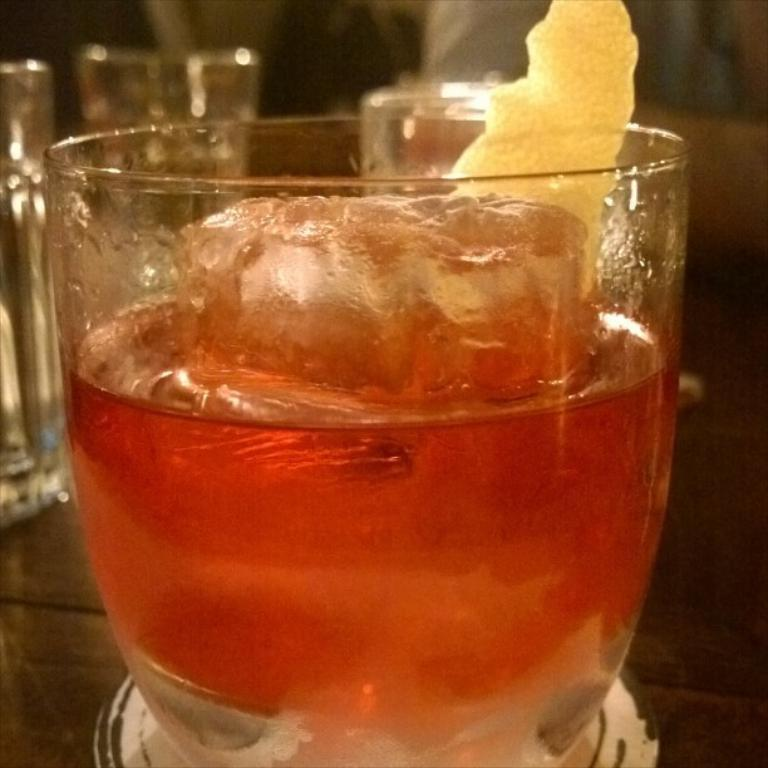What is in the glass that is visible in the image? The glass contains liquid and ice cubes. Are there any other ingredients in the glass? Yes, there are other ingredients in the glass. Where are the other glasses located in the image? The other glasses are in the background of the image, placed on a table. What hobbies does the glass enjoy in the image? The glass is an inanimate object and does not have hobbies. 